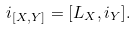<formula> <loc_0><loc_0><loc_500><loc_500>i _ { [ X , Y ] } = [ \L L _ { X } , i _ { Y } ] .</formula> 